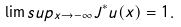<formula> <loc_0><loc_0><loc_500><loc_500>\lim s u p _ { x \to - \infty } J ^ { * } u ( x ) = 1 .</formula> 